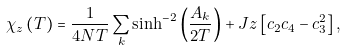<formula> <loc_0><loc_0><loc_500><loc_500>\chi _ { z } \left ( T \right ) = \frac { 1 } { 4 N T } \sum _ { k } \sinh ^ { - 2 } \left ( \frac { A _ { k } } { 2 T } \right ) + J z \left [ c _ { 2 } c _ { 4 } - c _ { 3 } ^ { 2 } \right ] ,</formula> 